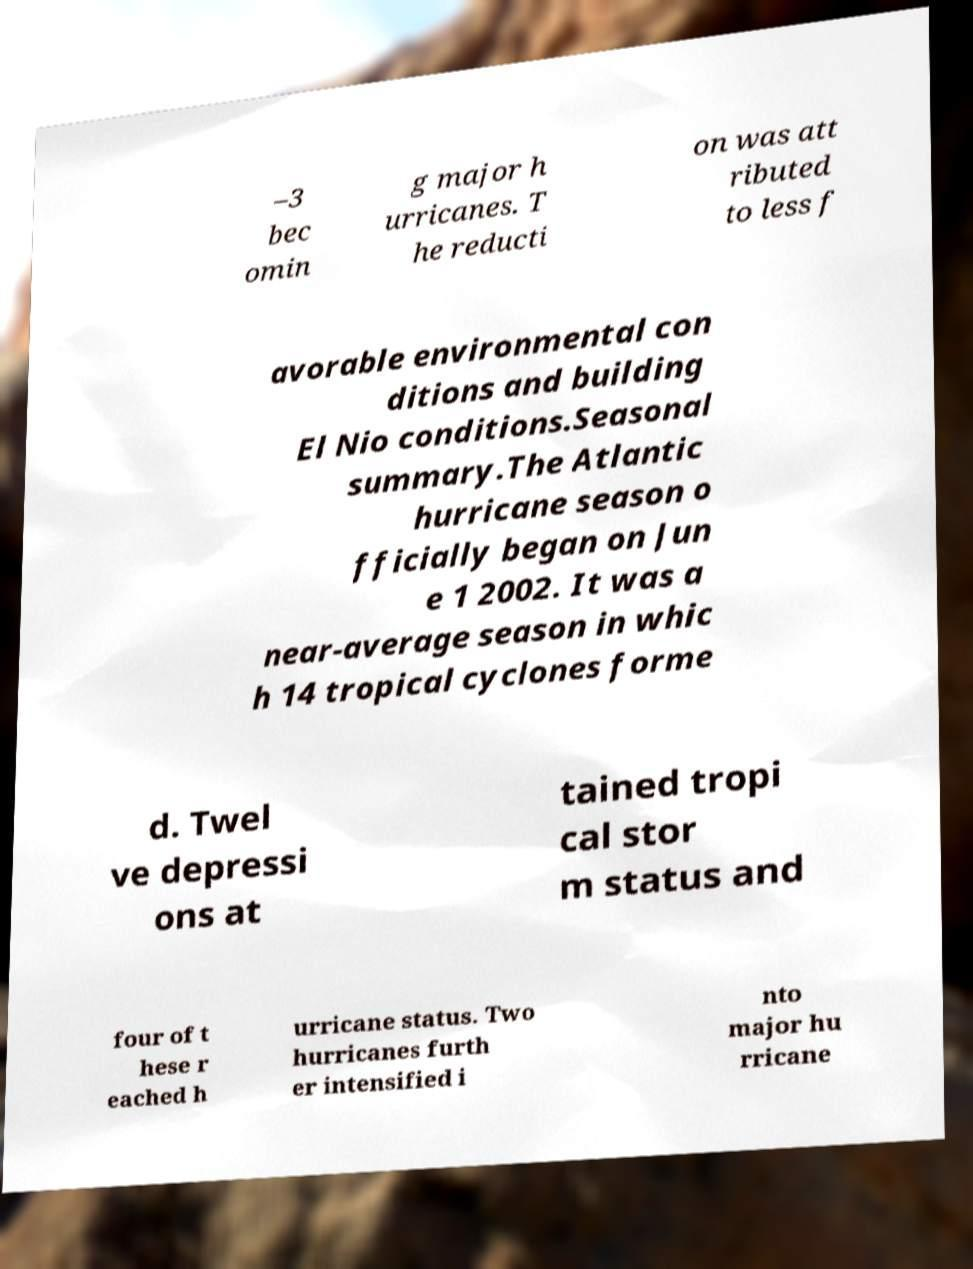For documentation purposes, I need the text within this image transcribed. Could you provide that? –3 bec omin g major h urricanes. T he reducti on was att ributed to less f avorable environmental con ditions and building El Nio conditions.Seasonal summary.The Atlantic hurricane season o fficially began on Jun e 1 2002. It was a near-average season in whic h 14 tropical cyclones forme d. Twel ve depressi ons at tained tropi cal stor m status and four of t hese r eached h urricane status. Two hurricanes furth er intensified i nto major hu rricane 